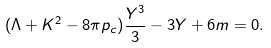Convert formula to latex. <formula><loc_0><loc_0><loc_500><loc_500>( \Lambda + { K ^ { 2 } } - { 8 \pi } p _ { c } ) \frac { Y ^ { 3 } } { 3 } - 3 Y + 6 m = 0 .</formula> 